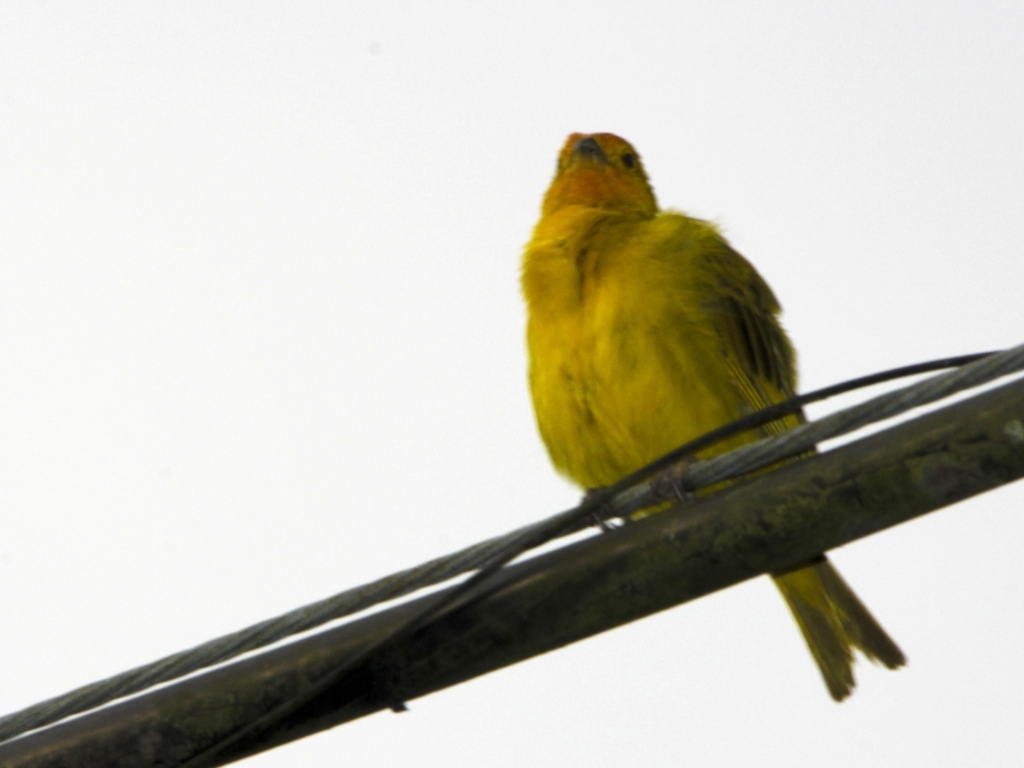What type of bird is this and is it common in its natural habitat? This appears to be a canary, known for their vibrant yellow feathers and melodious song. Canaries are relatively common in the wild and are also popular as domesticated pets. 